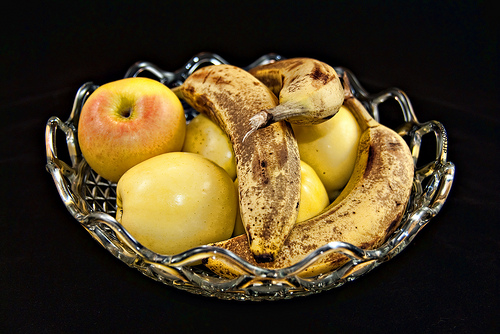<image>
Can you confirm if the apple is on the banana? No. The apple is not positioned on the banana. They may be near each other, but the apple is not supported by or resting on top of the banana. Is the apple behind the banana? No. The apple is not behind the banana. From this viewpoint, the apple appears to be positioned elsewhere in the scene. 